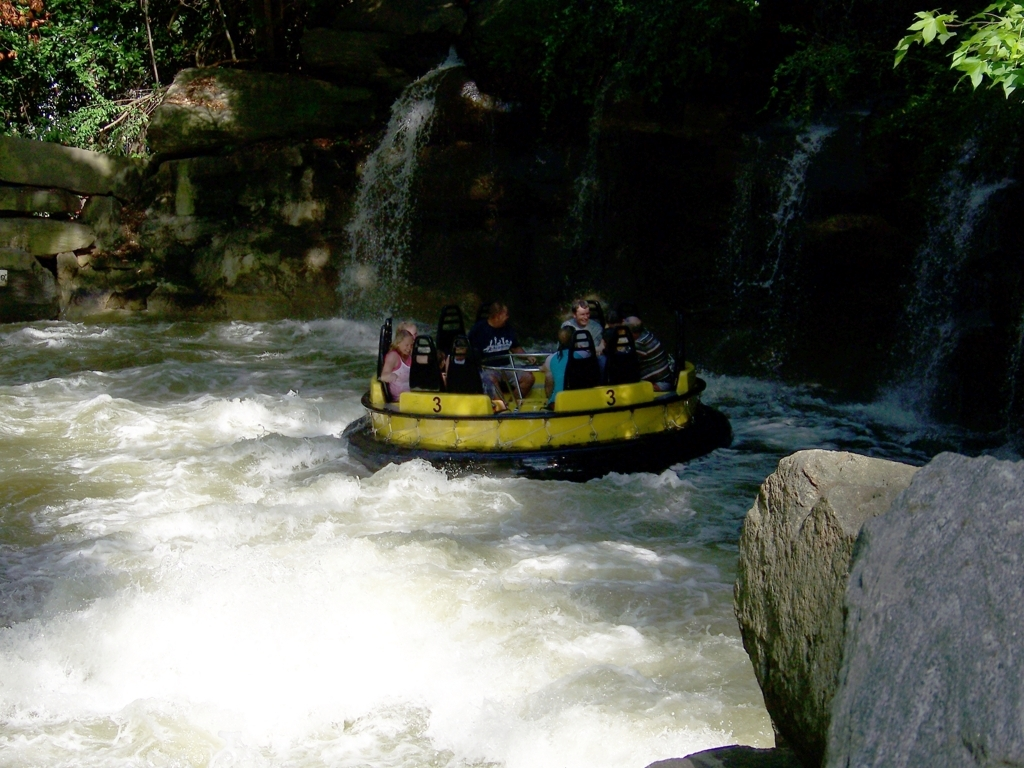What kind of activity are the people in the image engaging in? The individuals in the image are participating in a water-based recreational activity, likely rafting. They are seated in a circular raft, navigating through a turbulent section of a water course with splashes around them, suggestive of an exciting and adventurous experience. 